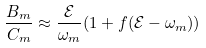<formula> <loc_0><loc_0><loc_500><loc_500>\frac { B _ { m } } { C _ { m } } \approx \frac { \mathcal { E } } { \omega _ { m } } ( 1 + f ( { \mathcal { E } } - \omega _ { m } ) )</formula> 